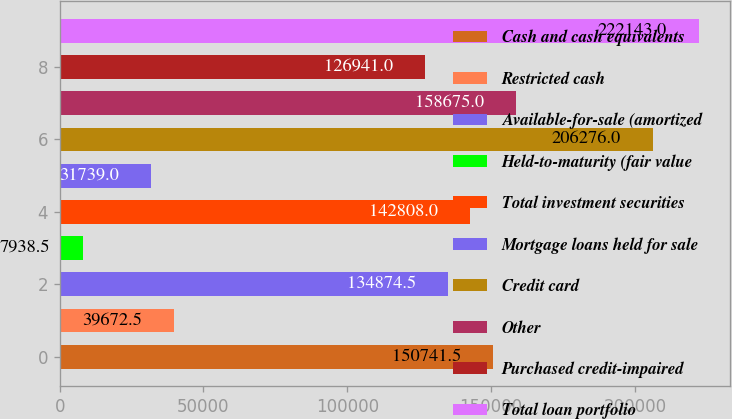Convert chart. <chart><loc_0><loc_0><loc_500><loc_500><bar_chart><fcel>Cash and cash equivalents<fcel>Restricted cash<fcel>Available-for-sale (amortized<fcel>Held-to-maturity (fair value<fcel>Total investment securities<fcel>Mortgage loans held for sale<fcel>Credit card<fcel>Other<fcel>Purchased credit-impaired<fcel>Total loan portfolio<nl><fcel>150742<fcel>39672.5<fcel>134874<fcel>7938.5<fcel>142808<fcel>31739<fcel>206276<fcel>158675<fcel>126941<fcel>222143<nl></chart> 